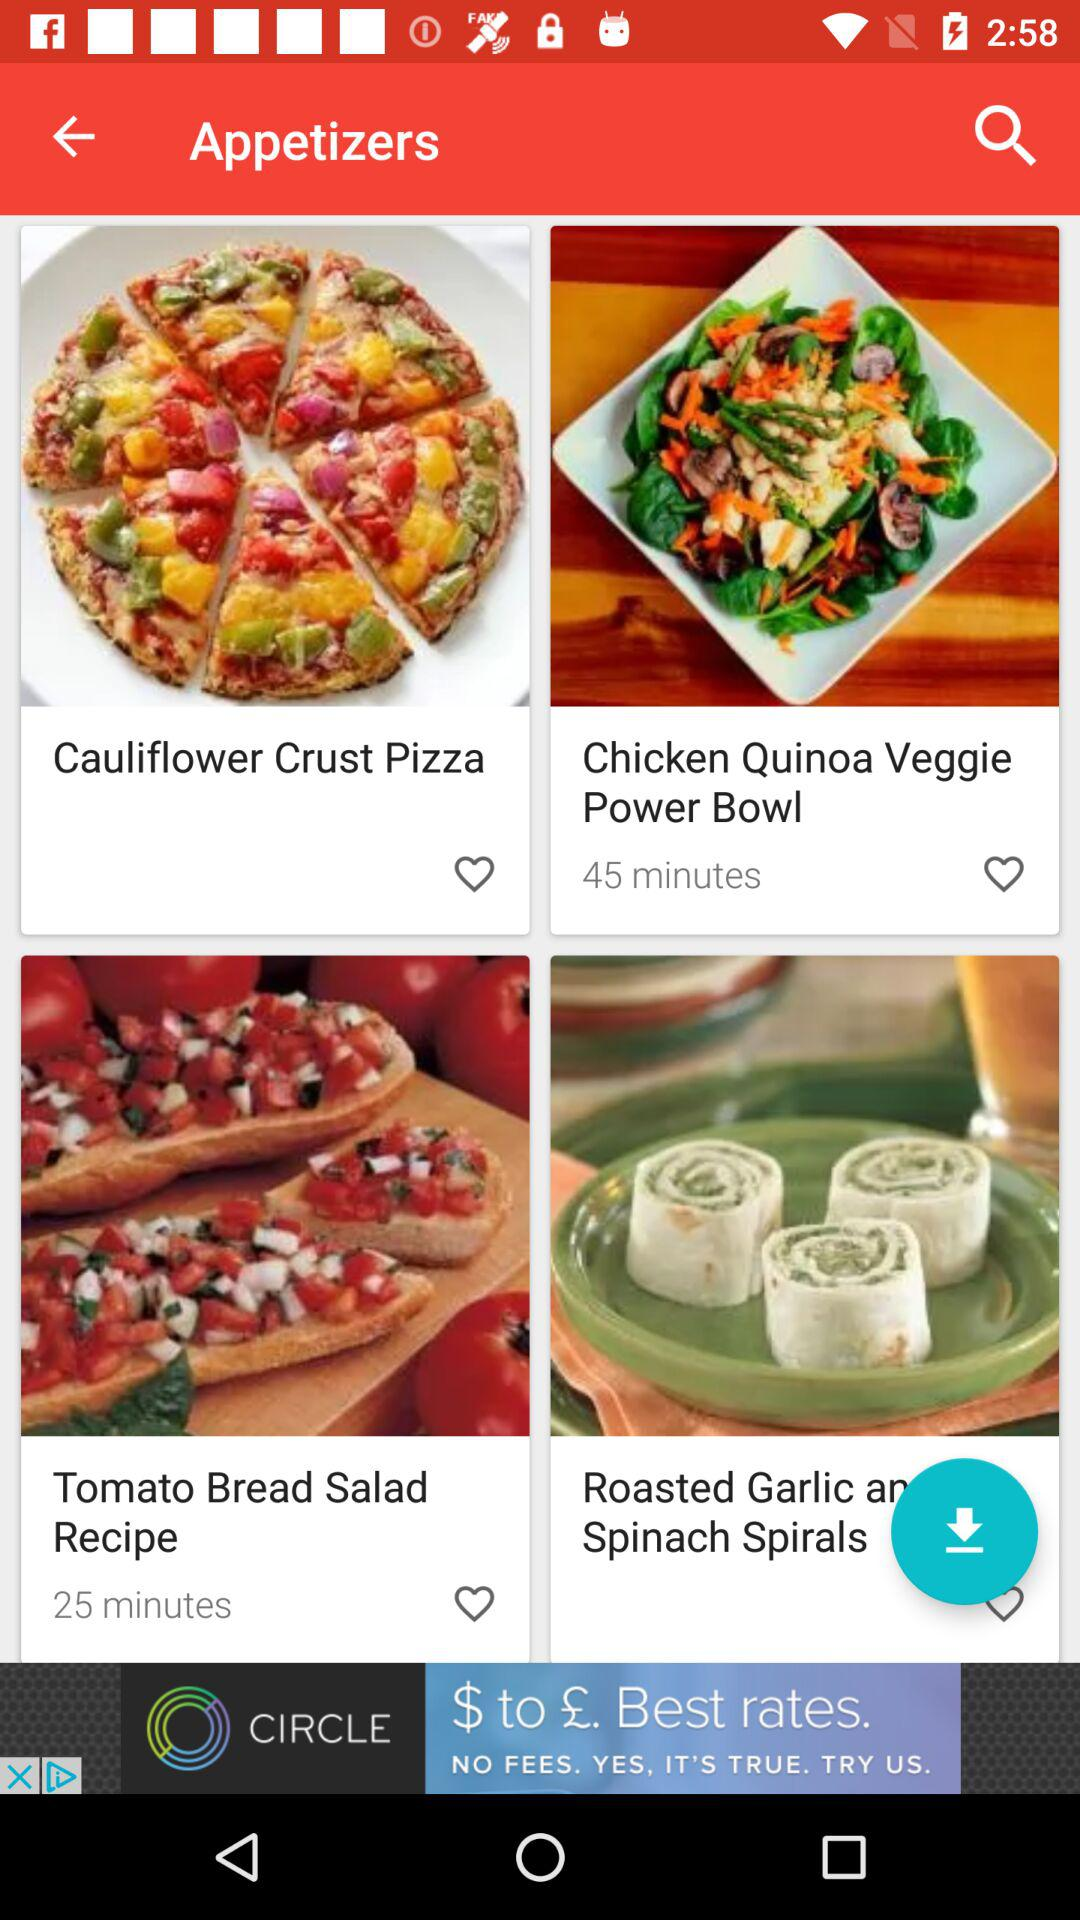How much time does it take to prepare a Chicken Quinoa Veggie Power Bowl? It takes 45 minutes to prepare a Chicken Quinoa Veggie Power Bowl. 